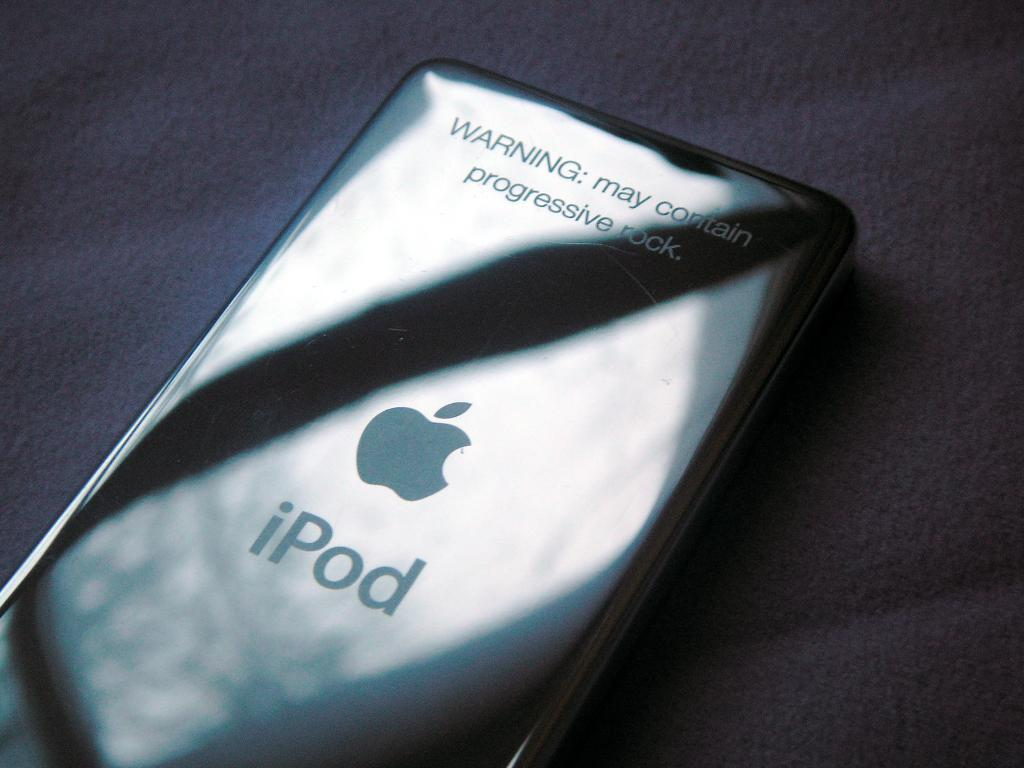Provide a one-sentence caption for the provided image. A silver iPod lays with the sun reflecting off its back. 